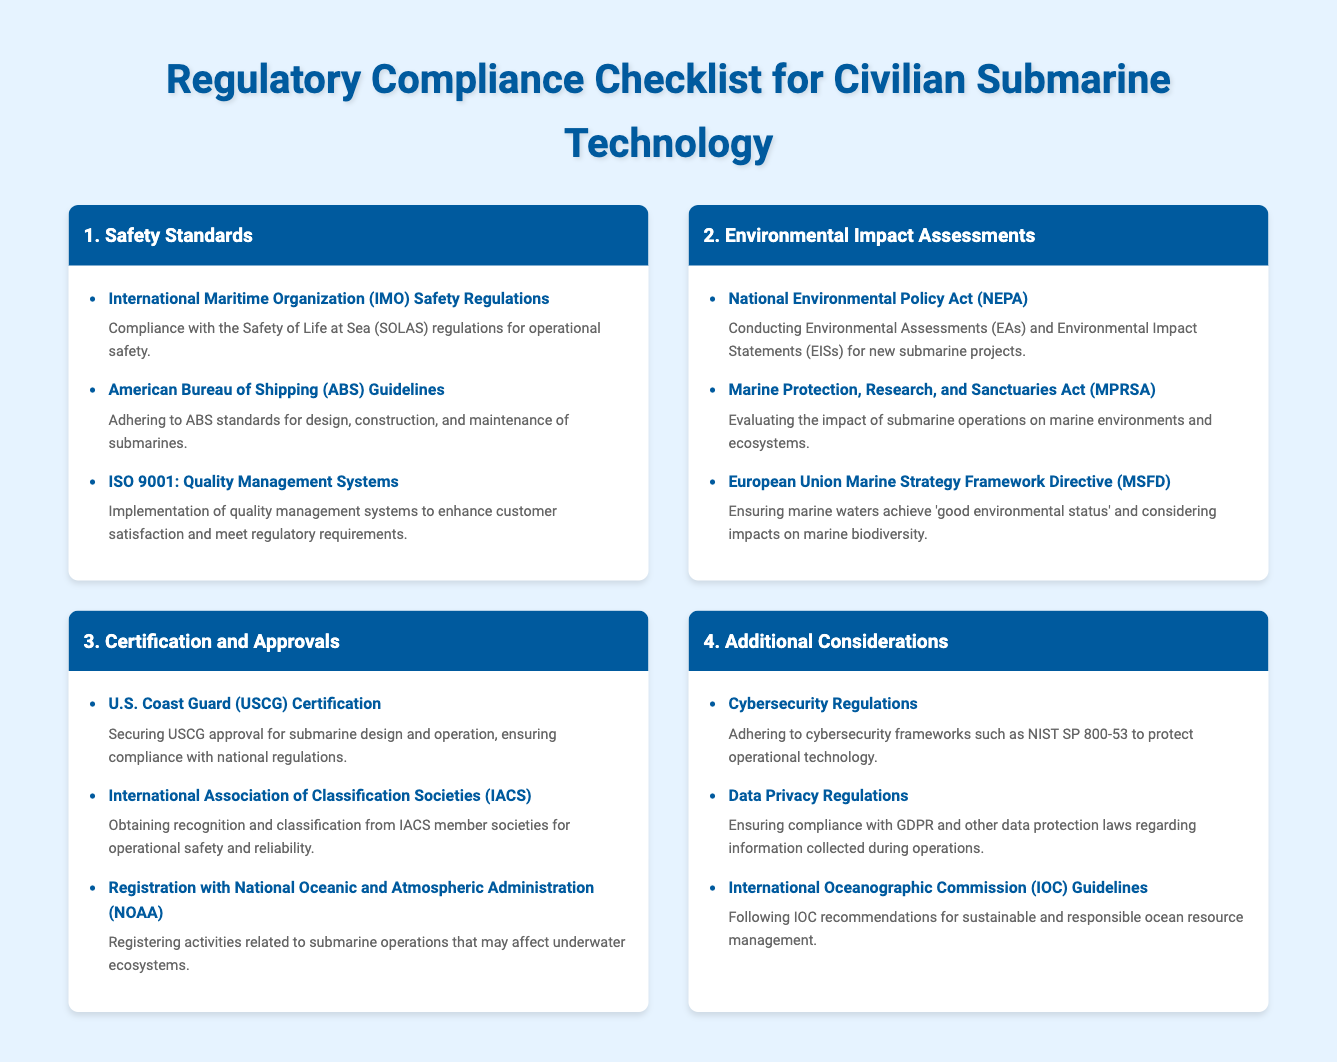What are the IMO Safety Regulations? The IMO Safety Regulations refer to the compliance with the Safety of Life at Sea (SOLAS) regulations for operational safety.
Answer: Compliance with the Safety of Life at Sea (SOLAS) regulations for operational safety What does ABS stand for? ABS stands for the American Bureau of Shipping, which provides guidelines for submarines.
Answer: American Bureau of Shipping How many safety standards are listed? The document lists a total of three safety standards under the Safety Standards section.
Answer: Three What is required under the National Environmental Policy Act (NEPA)? The National Environmental Policy Act (NEPA) requires conducting Environmental Assessments (EAs) and Environmental Impact Statements (EISs) for new submarine projects.
Answer: Conducting Environmental Assessments (EAs) and Environmental Impact Statements (EISs) for new submarine projects What certification does the U.S. Coast Guard provide? The U.S. Coast Guard provides certification for submarine design and operation, ensuring compliance with national regulations.
Answer: USCG approval for submarine design and operation What must be registered with NOAA? Activities related to submarine operations that may affect underwater ecosystems must be registered with the National Oceanic and Atmospheric Administration (NOAA).
Answer: Activities related to submarine operations that may affect underwater ecosystems What environmental directive does the EU follow? The European Union follows the Marine Strategy Framework Directive (MSFD) to ensure marine waters achieve 'good environmental status.'
Answer: European Union Marine Strategy Framework Directive (MSFD) How many additional considerations are mentioned? The document mentions three additional considerations for compliance in submarine technology.
Answer: Three What cybersecurity framework should be adhered to? The document mentions adhering to cybersecurity frameworks such as NIST SP 800-53.
Answer: NIST SP 800-53 